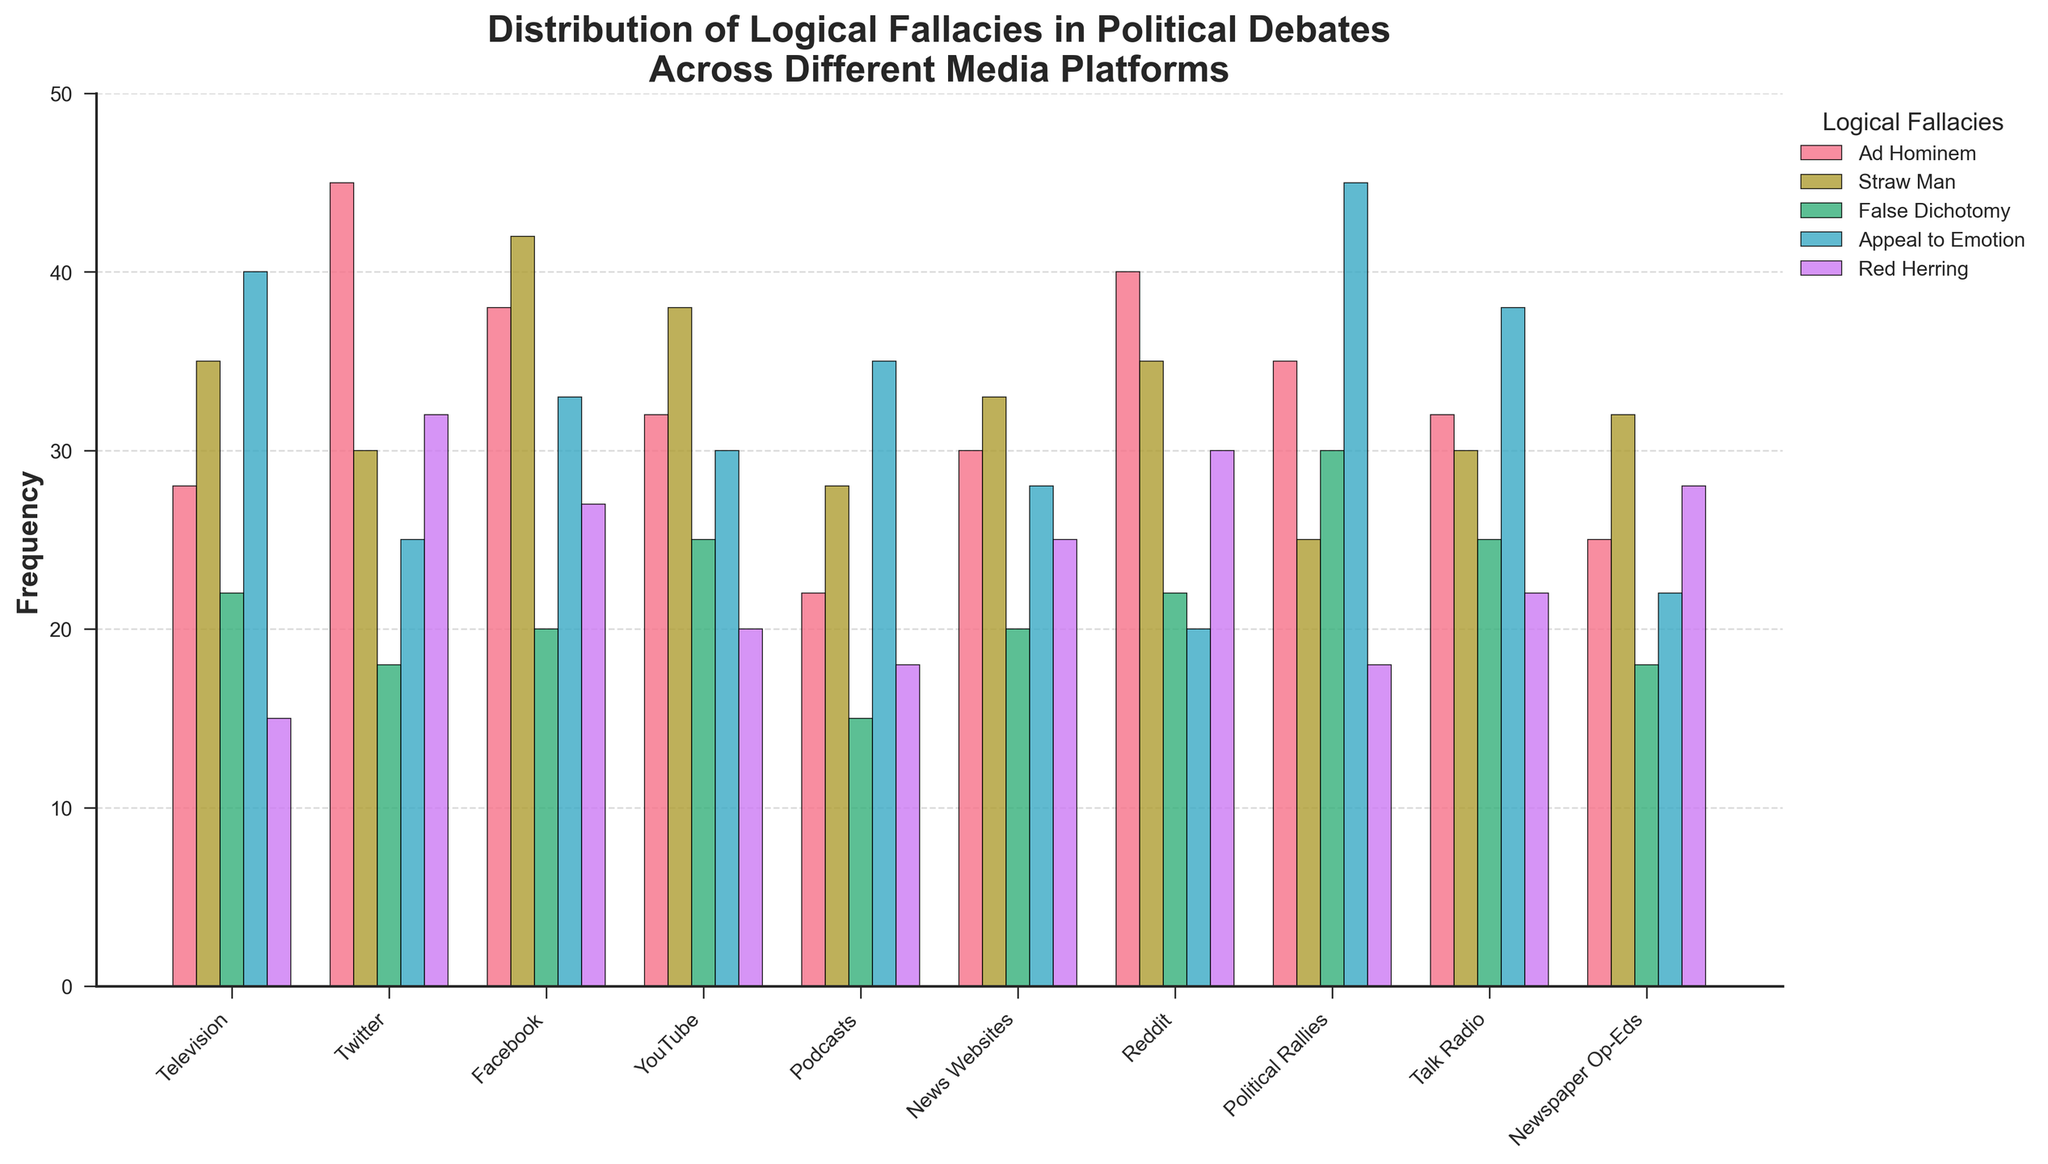What's the most frequently occurring logical fallacy on Twitter? Look at the bar heights representing Twitter and identify the tallest bar. The tallest bar on Twitter is for "Ad Hominem" at a height of 45.
Answer: Ad Hominem Which media platform has the highest frequency of Appeal to Emotion? Compare the heights of the bars representing Appeal to Emotion for each media platform. The highest bar for Appeal to Emotion is for Political Rallies at a height of 45.
Answer: Political Rallies On which media platform is the use of False Dichotomy the lowest? Compare the heights of the bars representing False Dichotomy for each media platform. The lowest bar for False Dichotomy is for Podcasts at a height of 15.
Answer: Podcasts What is the average frequency of Red Herring across all media platforms? Sum the frequencies of Red Herring for all platforms and divide by the number of platforms. (15+32+27+20+18+25+30+18+22+28) = 235, 235/10 = 23.5
Answer: 23.5 Is the frequency of Straw Man higher on Facebook or YouTube? Compare the heights of the bars representing Straw Man for Facebook and YouTube. The height of the bar for Facebook is 42, and for YouTube is 38; thus, Facebook is higher.
Answer: Facebook What is the total frequency of Ad Hominem across Television, Twitter, and Facebook? Sum the frequencies of Ad Hominem for Television, Twitter, and Facebook. (28+45+38)=111.
Answer: 111 Which logical fallacy is used the least on News Websites? Identify the shortest bar for News Websites. The shortest bar is for False Dichotomy at a height of 20.
Answer: False Dichotomy How does the frequency of Red Herring on Reddit compare to Twitter? Compare the heights of the bars representing Red Herring for Reddit and Twitter. The height of the bar for Reddit is 30, and for Twitter is 32; thus, Twitter is higher.
Answer: Twitter What is the sum of Appeal to Emotion and Red Herring on Talk Radio? Add the frequencies of Appeal to Emotion and Red Herring for Talk Radio. (38+22)=60.
Answer: 60 